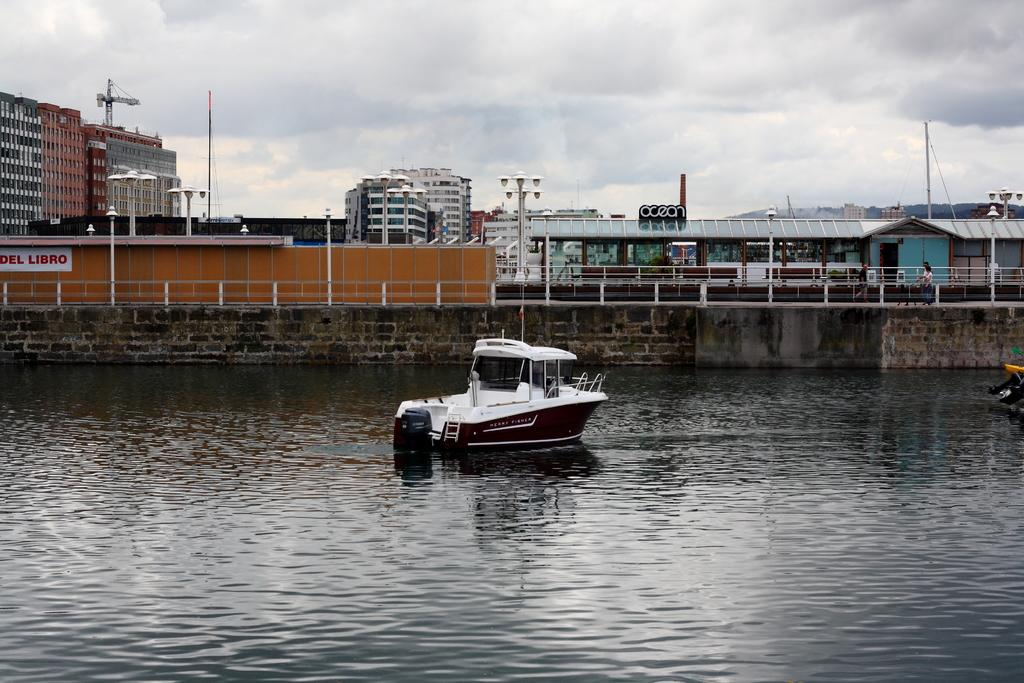<image>
Relay a brief, clear account of the picture shown. A single white and black motor boat is floating by a wall that says Del Libro. 